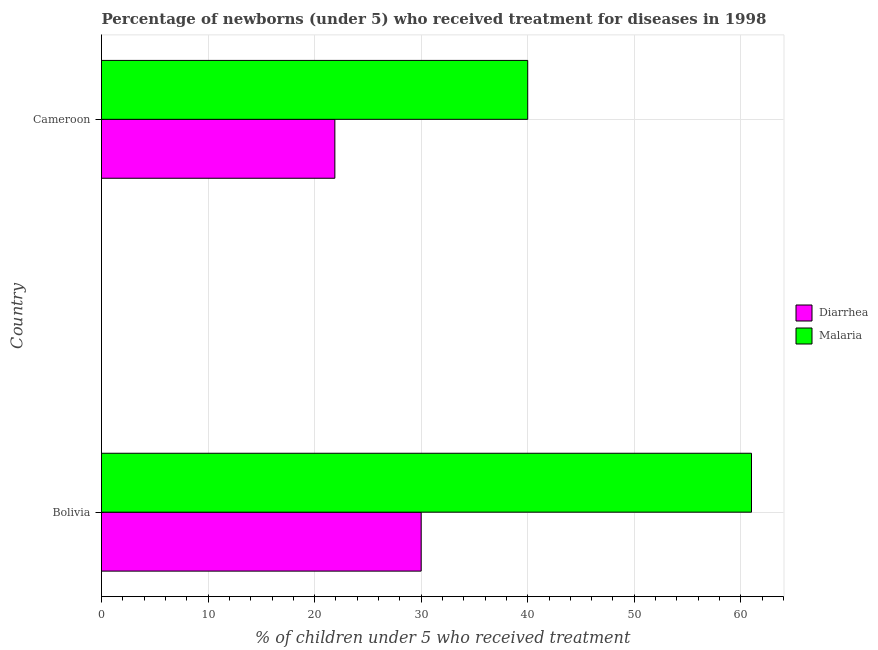How many different coloured bars are there?
Your answer should be compact. 2. How many groups of bars are there?
Your response must be concise. 2. What is the label of the 1st group of bars from the top?
Your answer should be very brief. Cameroon. In how many cases, is the number of bars for a given country not equal to the number of legend labels?
Your response must be concise. 0. What is the percentage of children who received treatment for malaria in Cameroon?
Offer a terse response. 40. Across all countries, what is the maximum percentage of children who received treatment for malaria?
Offer a very short reply. 61. Across all countries, what is the minimum percentage of children who received treatment for diarrhoea?
Offer a very short reply. 21.9. In which country was the percentage of children who received treatment for diarrhoea minimum?
Make the answer very short. Cameroon. What is the total percentage of children who received treatment for malaria in the graph?
Your response must be concise. 101. What is the difference between the percentage of children who received treatment for malaria in Bolivia and that in Cameroon?
Offer a terse response. 21. What is the average percentage of children who received treatment for diarrhoea per country?
Ensure brevity in your answer.  25.95. What is the difference between the percentage of children who received treatment for diarrhoea and percentage of children who received treatment for malaria in Bolivia?
Your answer should be very brief. -31. What is the ratio of the percentage of children who received treatment for malaria in Bolivia to that in Cameroon?
Ensure brevity in your answer.  1.52. Is the percentage of children who received treatment for malaria in Bolivia less than that in Cameroon?
Your answer should be compact. No. What does the 2nd bar from the top in Bolivia represents?
Offer a terse response. Diarrhea. What does the 2nd bar from the bottom in Cameroon represents?
Offer a terse response. Malaria. How many bars are there?
Give a very brief answer. 4. How many legend labels are there?
Provide a succinct answer. 2. How are the legend labels stacked?
Make the answer very short. Vertical. What is the title of the graph?
Offer a very short reply. Percentage of newborns (under 5) who received treatment for diseases in 1998. What is the label or title of the X-axis?
Provide a short and direct response. % of children under 5 who received treatment. What is the label or title of the Y-axis?
Provide a short and direct response. Country. What is the % of children under 5 who received treatment of Diarrhea in Cameroon?
Your response must be concise. 21.9. Across all countries, what is the maximum % of children under 5 who received treatment of Malaria?
Provide a succinct answer. 61. Across all countries, what is the minimum % of children under 5 who received treatment of Diarrhea?
Provide a succinct answer. 21.9. What is the total % of children under 5 who received treatment in Diarrhea in the graph?
Offer a very short reply. 51.9. What is the total % of children under 5 who received treatment of Malaria in the graph?
Ensure brevity in your answer.  101. What is the difference between the % of children under 5 who received treatment in Diarrhea in Bolivia and the % of children under 5 who received treatment in Malaria in Cameroon?
Offer a very short reply. -10. What is the average % of children under 5 who received treatment of Diarrhea per country?
Offer a terse response. 25.95. What is the average % of children under 5 who received treatment in Malaria per country?
Provide a succinct answer. 50.5. What is the difference between the % of children under 5 who received treatment in Diarrhea and % of children under 5 who received treatment in Malaria in Bolivia?
Your answer should be very brief. -31. What is the difference between the % of children under 5 who received treatment in Diarrhea and % of children under 5 who received treatment in Malaria in Cameroon?
Provide a succinct answer. -18.1. What is the ratio of the % of children under 5 who received treatment of Diarrhea in Bolivia to that in Cameroon?
Offer a terse response. 1.37. What is the ratio of the % of children under 5 who received treatment of Malaria in Bolivia to that in Cameroon?
Provide a short and direct response. 1.52. What is the difference between the highest and the second highest % of children under 5 who received treatment of Diarrhea?
Provide a succinct answer. 8.1. 